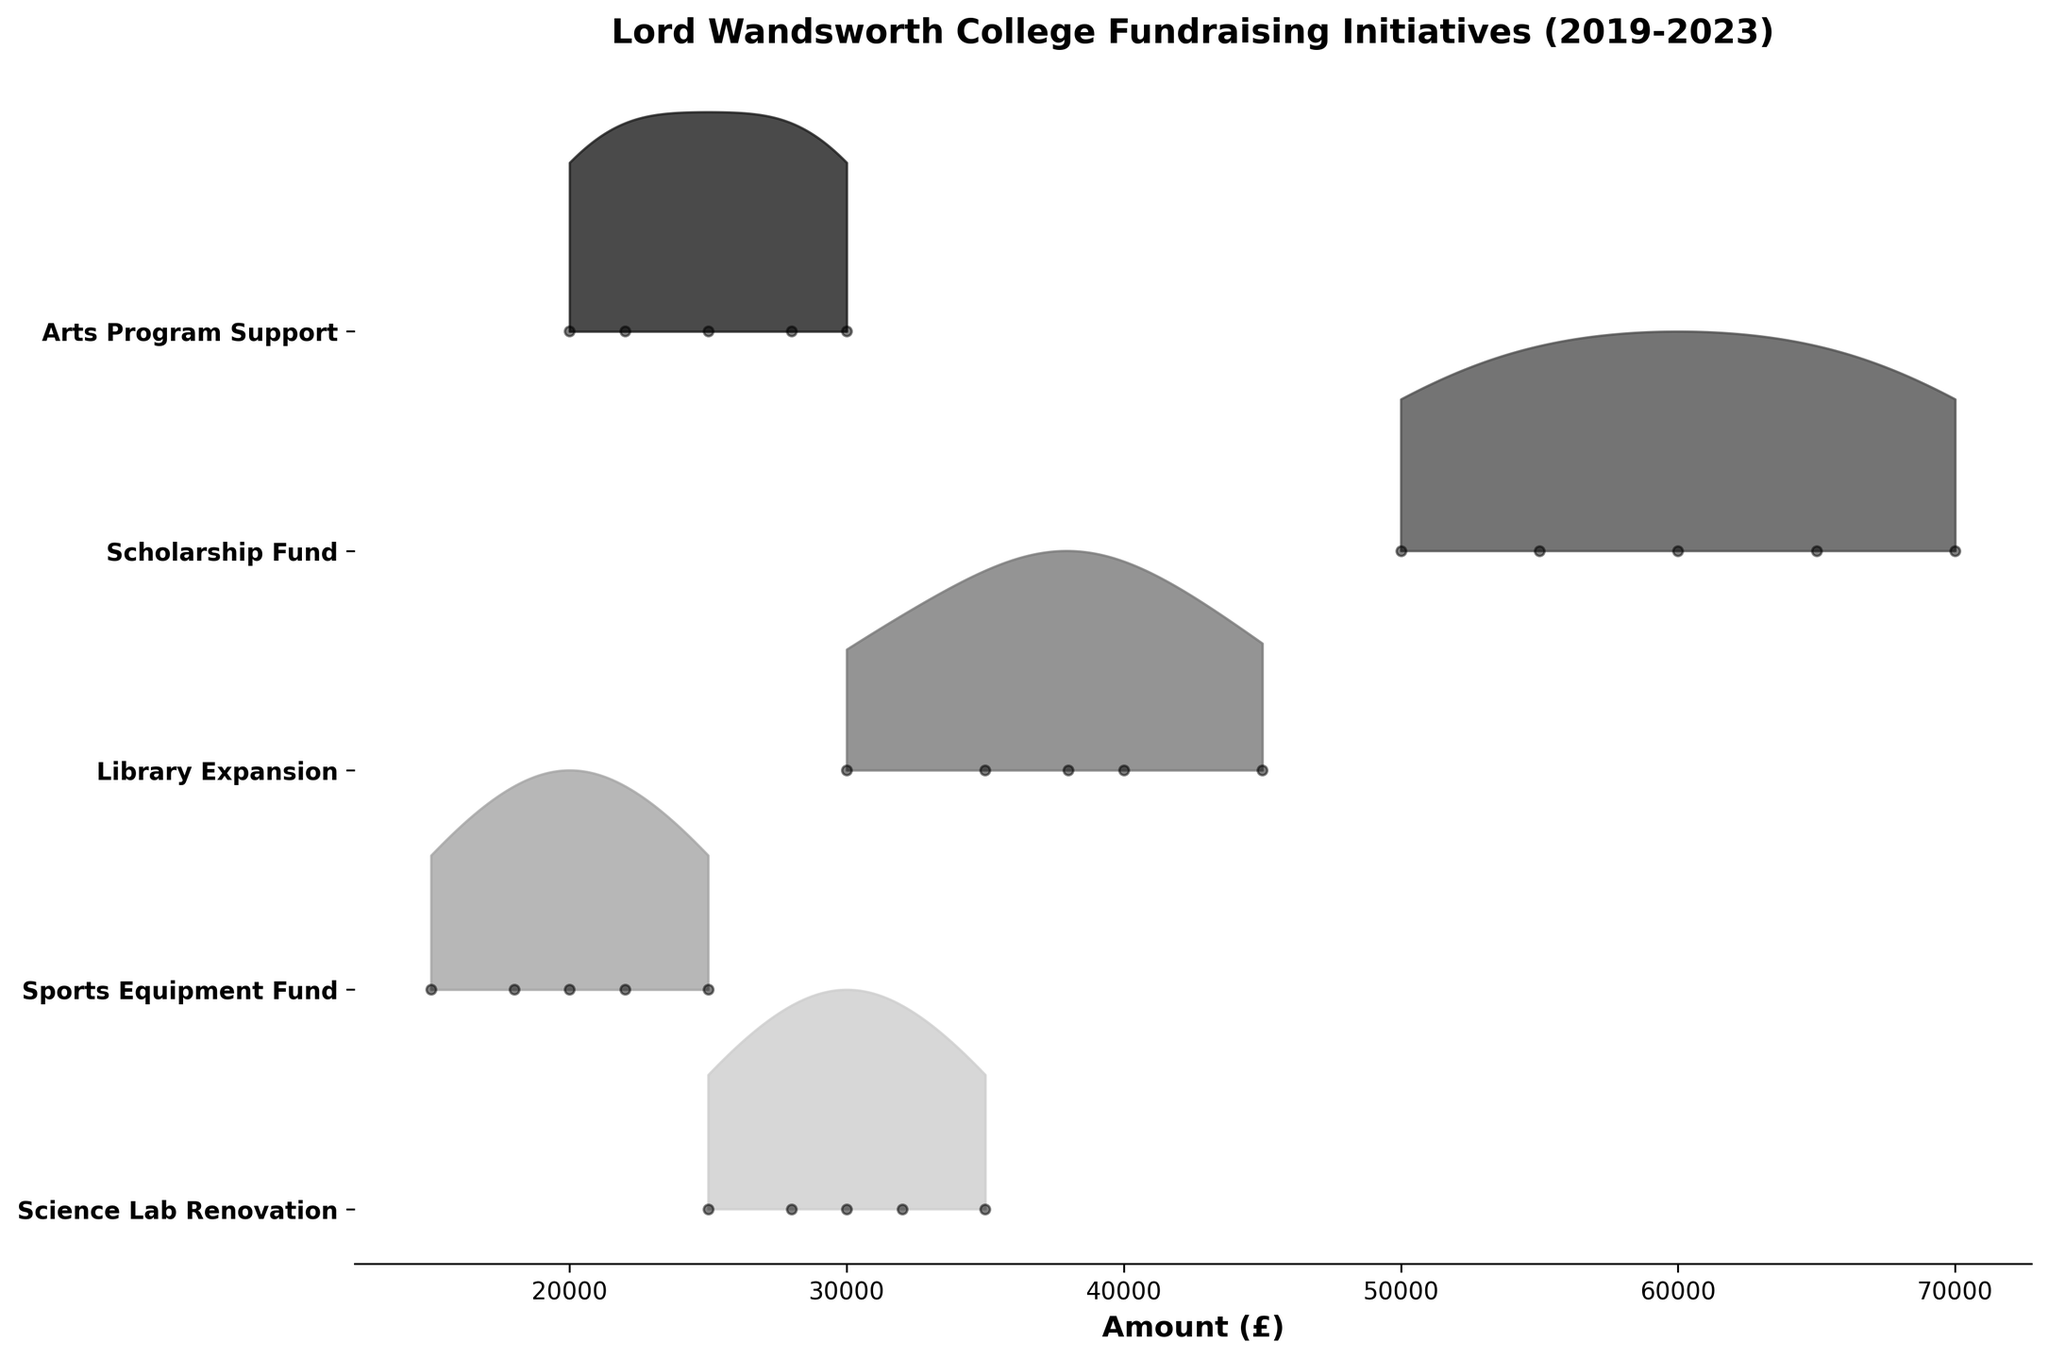What's the title of the plot? The title of the plot is displayed at the top center of the figure.
Answer: Lord Wandsworth College Fundraising Initiatives (2019-2023) Which initiative received the highest funding in 2023? By looking at the data points for the year 2023 along the vertical axis, we can see which initiative has the highest amount.
Answer: Scholarship Fund What’s the total amount raised for the Science Lab Renovation initiative from 2019 to 2023? Sum the amounts for the Science Lab Renovation initiative across all the years: 25000 + 28000 + 30000 + 32000 + 35000 = 150000.
Answer: 150000 Which initiative shows the greatest increase in fundraising amounts between 2019 and 2023? Compare the amounts from 2019 to 2023 for each initiative and identify the one with the highest increase. The Science Lab Renovation increased from 25000 to 35000, Sports Equipment Fund from 15000 to 25000, Library Expansion from 30000 to 45000, Scholarship Fund from 50000 to 70000, and Arts Program Support from 20000 to 30000. The largest change is with the Scholarship Fund (20000).
Answer: Scholarship Fund Which two initiatives had the most similar amounts in 2021? Look for initiatives where the amounts are close in value for the year 2021: Science Lab Renovation (30000), Sports Equipment Fund (20000), Library Expansion (38000), Scholarship Fund (60000), Arts Program Support (25000). Comparing these values, Sports Equipment Fund and Arts Program Support are closest (20000 and 25000).
Answer: Sports Equipment Fund and Arts Program Support On average, how much was raised per year for the Library Expansion initiative? Sum the total amounts raised for Library Expansion across all years and then divide by the number of years: (30000 + 35000 + 38000 + 40000 + 45000) / 5 = 37600.
Answer: 37600 Which initiatives have their peak annual amounts represented with the darkest shade on the plot? The darkest shade in the grayscale indicates the highest annual amounts. By identifying the data points with the highest amounts, we see that the Scholarship Fund initiative shows the peak amounts in darkest shade.
Answer: Scholarship Fund What is the range of fundraising amounts achieved for the Arts Program Support initiative? Identify the smallest and largest amounts raised for Arts Program Support over the years. 20000 (2019) and 30000 (2023), so the range is 30000 - 20000 = 10000.
Answer: 10000 Did any initiative show a constant increase in funding over the years? We need to check each initiative to see if it increases every year. The Science Lab Renovation shows continuous annual increase: 25000, 28000, 30000, 32000, 35000.
Answer: Science Lab Renovation 